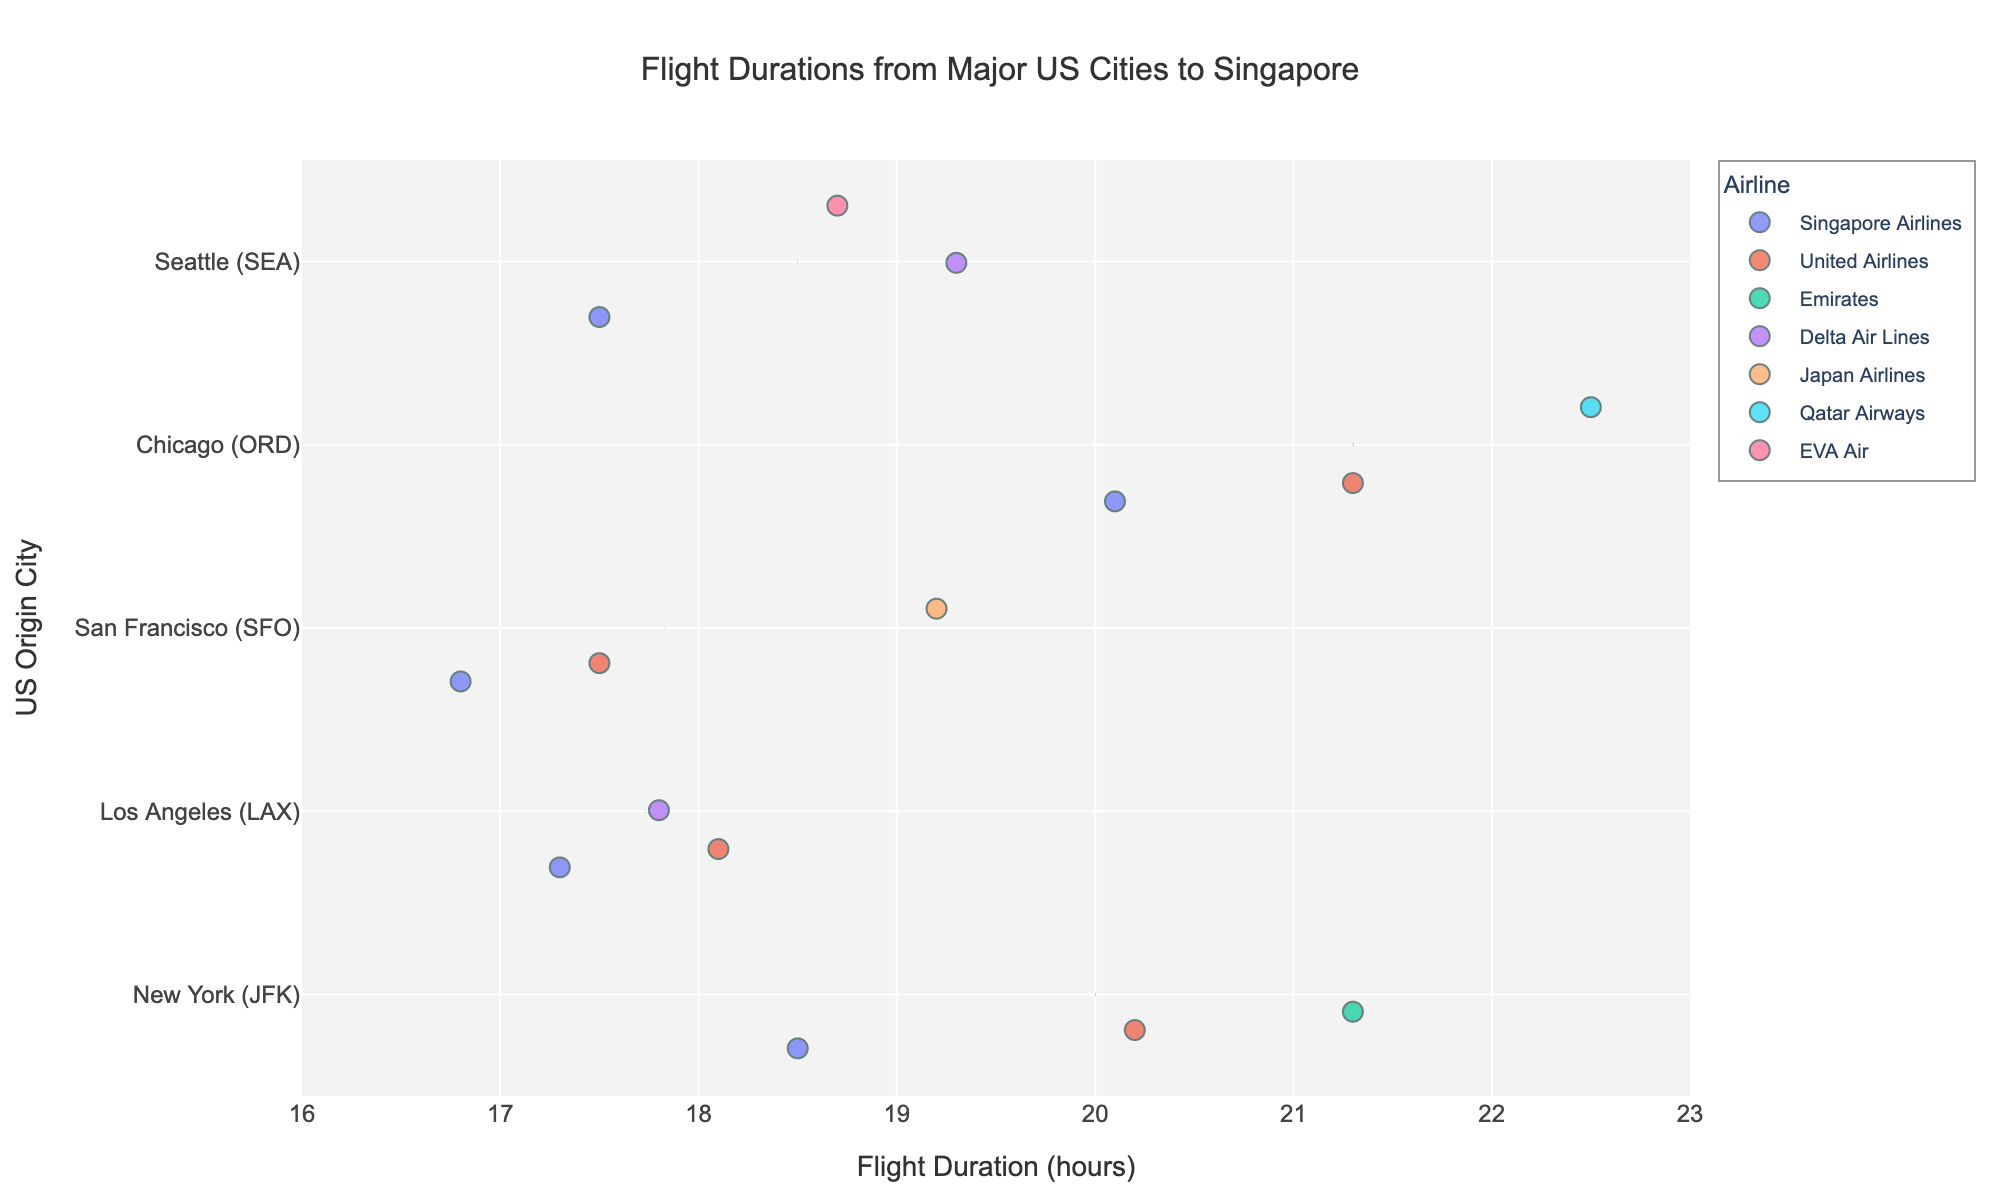What's the title of the figure? The title of the figure is prominently displayed at the top and summarizes the content of the plot. The eye is naturally drawn to it.
Answer: Flight Durations from Major US Cities to Singapore Which US city has the shortest average flight duration to Singapore? By observing the red dashed average lines for each origin city, the line that is farthest left represents the shortest average duration.
Answer: San Francisco (SFO) Which airline offers the longest flight duration from New York (JFK) to Singapore? By locating the data points for New York (JFK) on the y-axis and identifying the point farthest to the right, we can determine the airline with the longest flight duration.
Answer: Emirates What is the range of flight durations from San Francisco (SFO) to Singapore? By checking the spread of data points from San Francisco (SFO) along the x-axis, the minimum and maximum values can be identified and used to calculate the range.
Answer: 16.8 to 19.2 hours Are there any cities where Singapore Airlines has the shortest flight duration to Singapore? By looking at the position of Singapore Airlines' data points in relation to other airlines' points for each city, we can identify the cities where its flights are the shortest.
Answer: Los Angeles (LAX) and San Francisco (SFO) What's the average flight duration from Los Angeles (LAX) to Singapore? The red dashed line for Los Angeles (LAX) indicates the average duration.
Answer: 17.73 hours Which airline operates the most flights with durations over 20 hours? By scanning the data points above the 20-hour mark and tallying the points per airline, we can identify the airline with the most.
Answer: United Airlines How does the flight duration from Seattle (SEA) via Delta Air Lines compare to that via Singapore Airlines? Comparing the position of Delta Air Lines' and Singapore Airlines' data points on the x-axis for Seattle (SEA) reveals the differences in duration.
Answer: Delta Air Lines is longer What is the difference in flight duration from Chicago (ORD) via Singapore Airlines and Qatar Airways? Identify Singapore Airlines' and Qatar Airways' data points for Chicago (ORD) on the x-axis, then subtract the former's duration from the latter's.
Answer: 2.4 hours How many airlines have flights from San Francisco (SFO) to Singapore? Counting the unique airlines represented by the data points for San Francisco (SFO) on the y-axis.
Answer: 3 